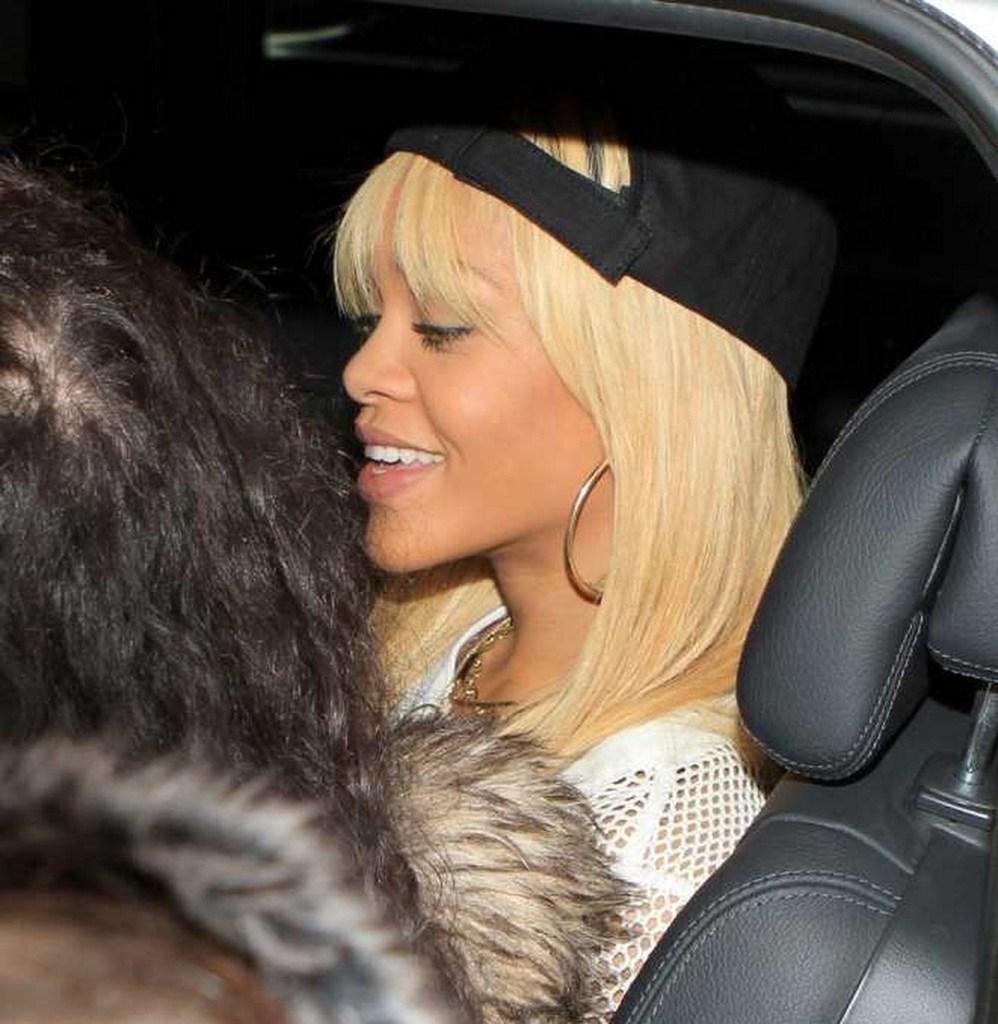Can you describe this image briefly? There is a woman wearing black hat is sitting in the car and there is another person sitting beside her. 